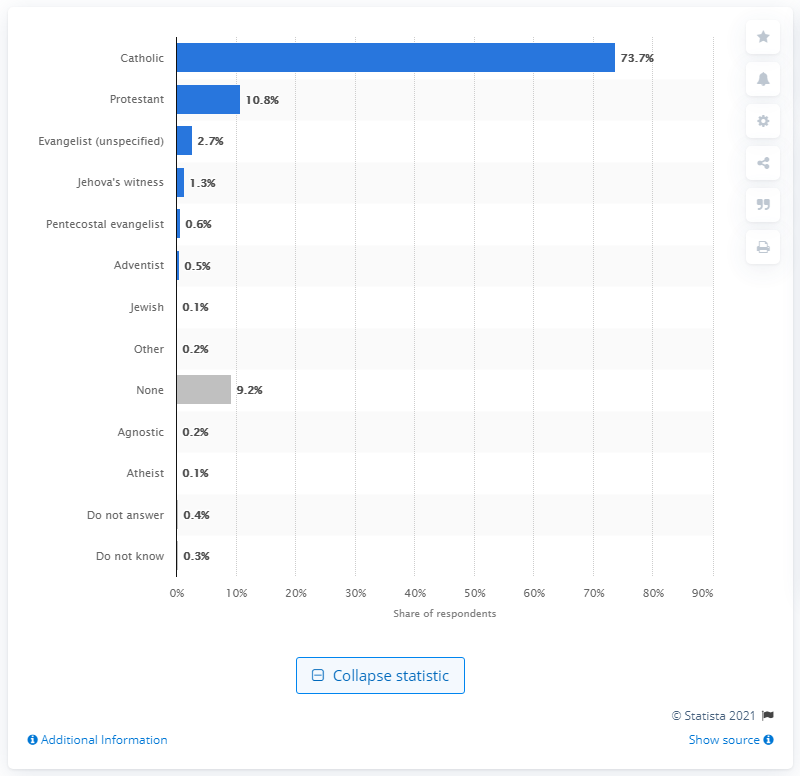Mention a couple of crucial points in this snapshot. According to a survey conducted in Colombia, approximately 0.3% of the population self-identified as agnostic or atheist. 